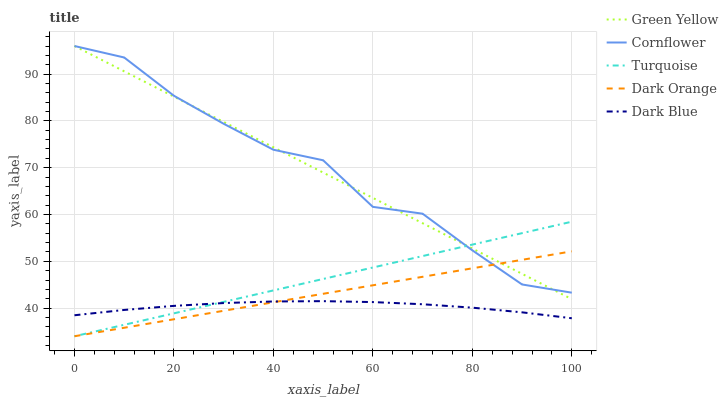Does Dark Blue have the minimum area under the curve?
Answer yes or no. Yes. Does Cornflower have the maximum area under the curve?
Answer yes or no. Yes. Does Turquoise have the minimum area under the curve?
Answer yes or no. No. Does Turquoise have the maximum area under the curve?
Answer yes or no. No. Is Dark Orange the smoothest?
Answer yes or no. Yes. Is Cornflower the roughest?
Answer yes or no. Yes. Is Turquoise the smoothest?
Answer yes or no. No. Is Turquoise the roughest?
Answer yes or no. No. Does Turquoise have the lowest value?
Answer yes or no. Yes. Does Green Yellow have the lowest value?
Answer yes or no. No. Does Green Yellow have the highest value?
Answer yes or no. Yes. Does Turquoise have the highest value?
Answer yes or no. No. Is Dark Blue less than Green Yellow?
Answer yes or no. Yes. Is Cornflower greater than Dark Blue?
Answer yes or no. Yes. Does Dark Orange intersect Dark Blue?
Answer yes or no. Yes. Is Dark Orange less than Dark Blue?
Answer yes or no. No. Is Dark Orange greater than Dark Blue?
Answer yes or no. No. Does Dark Blue intersect Green Yellow?
Answer yes or no. No. 